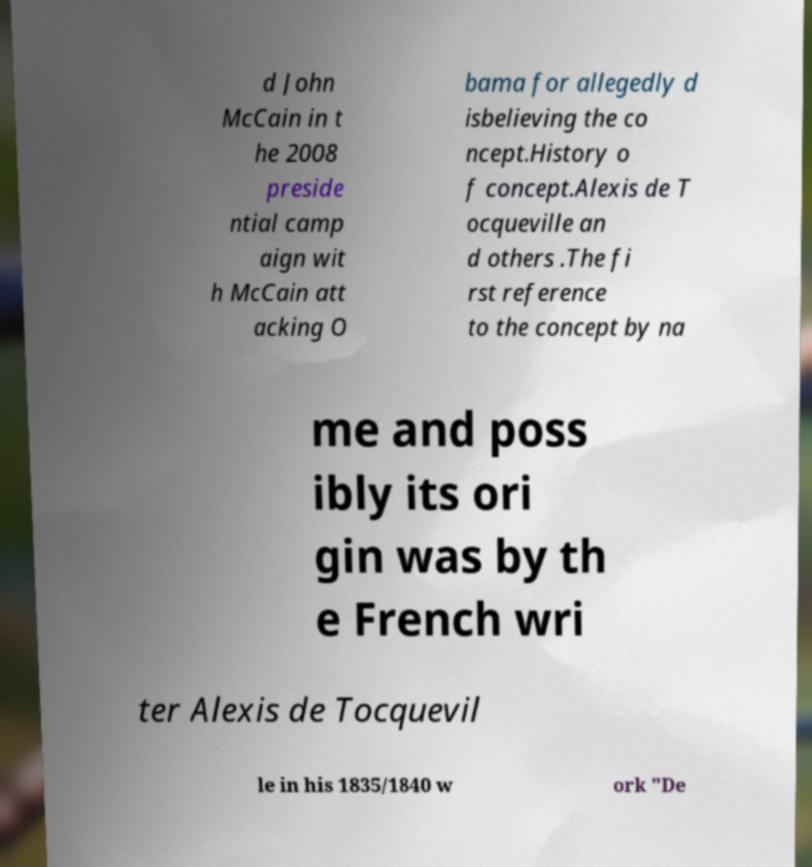I need the written content from this picture converted into text. Can you do that? d John McCain in t he 2008 preside ntial camp aign wit h McCain att acking O bama for allegedly d isbelieving the co ncept.History o f concept.Alexis de T ocqueville an d others .The fi rst reference to the concept by na me and poss ibly its ori gin was by th e French wri ter Alexis de Tocquevil le in his 1835/1840 w ork "De 